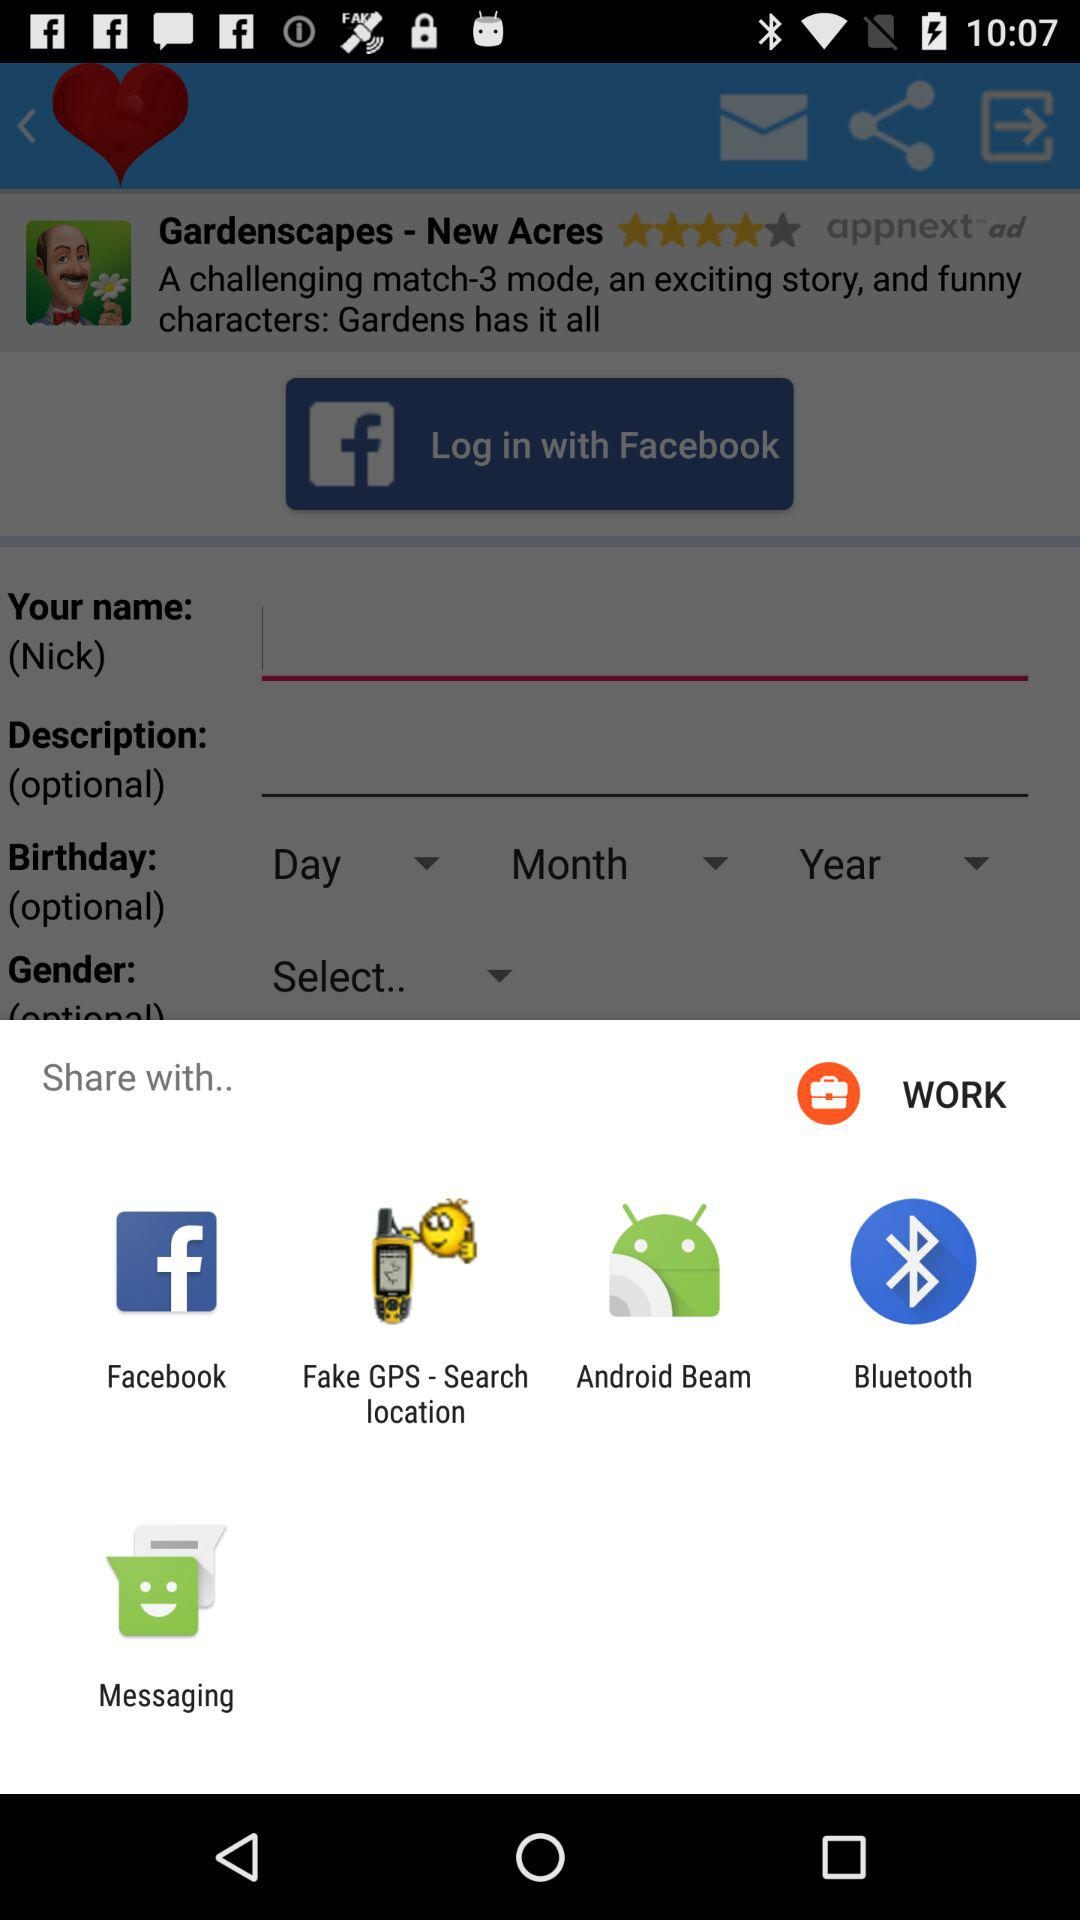Which are the options available that can be shared? The options available are "Facebook", "Fake GPS - Search location", "Android Beam", "Bluetooth" and "Messaging". 